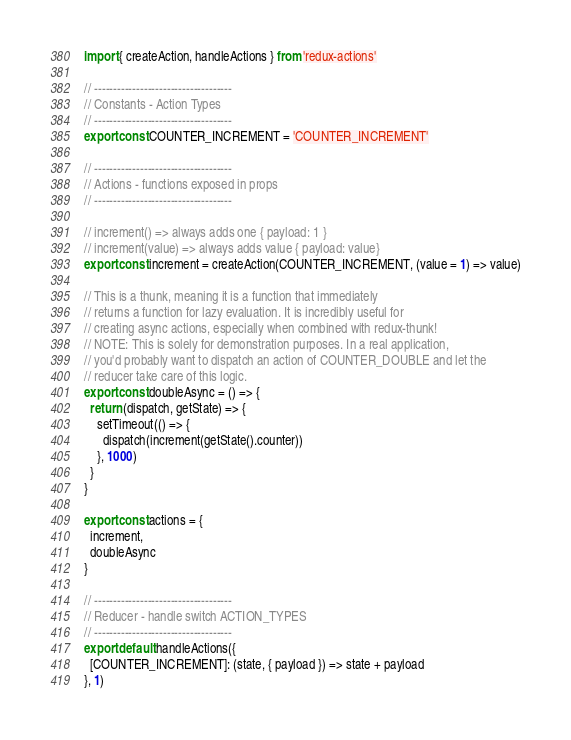Convert code to text. <code><loc_0><loc_0><loc_500><loc_500><_JavaScript_>import { createAction, handleActions } from 'redux-actions'

// ------------------------------------
// Constants - Action Types
// ------------------------------------
export const COUNTER_INCREMENT = 'COUNTER_INCREMENT'

// ------------------------------------
// Actions - functions exposed in props
// ------------------------------------

// increment() => always adds one { payload: 1 }
// increment(value) => always adds value { payload: value}
export const increment = createAction(COUNTER_INCREMENT, (value = 1) => value)

// This is a thunk, meaning it is a function that immediately
// returns a function for lazy evaluation. It is incredibly useful for
// creating async actions, especially when combined with redux-thunk!
// NOTE: This is solely for demonstration purposes. In a real application,
// you'd probably want to dispatch an action of COUNTER_DOUBLE and let the
// reducer take care of this logic.
export const doubleAsync = () => {
  return (dispatch, getState) => {
    setTimeout(() => {
      dispatch(increment(getState().counter))
    }, 1000)
  }
}

export const actions = {
  increment,
  doubleAsync
}

// ------------------------------------
// Reducer - handle switch ACTION_TYPES
// ------------------------------------
export default handleActions({
  [COUNTER_INCREMENT]: (state, { payload }) => state + payload
}, 1)
</code> 